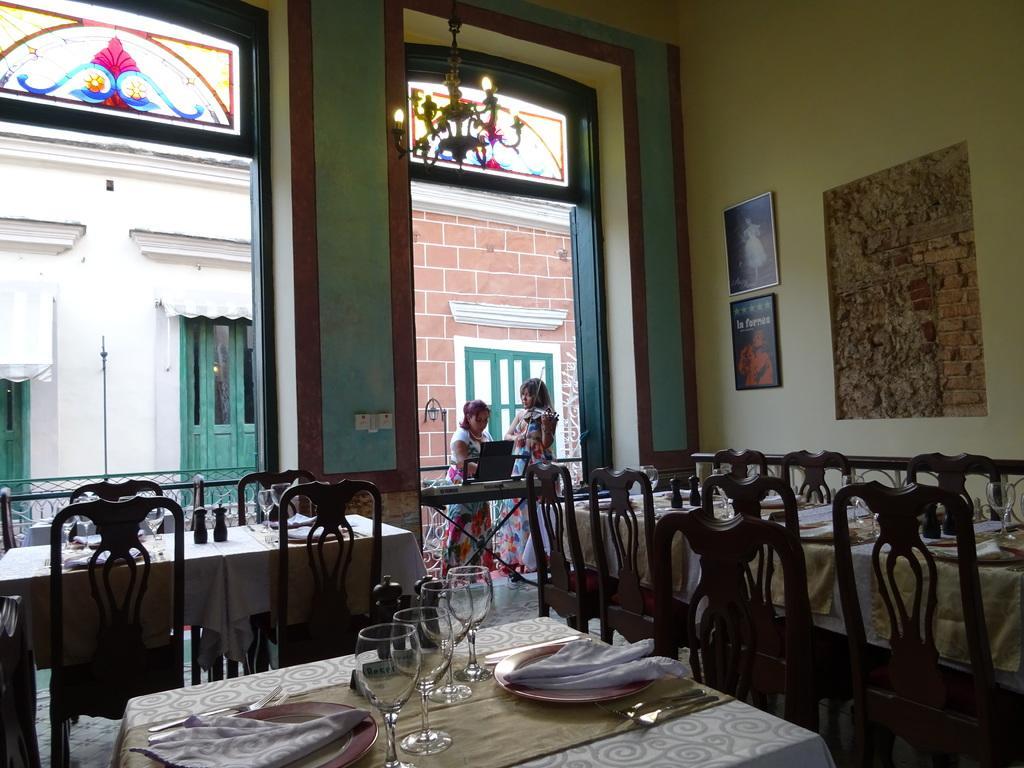Describe this image in one or two sentences. At the bottom of the image there are some chairs and tables, on the tables there are some glasses and plates and spoons and forks. Behind the table there is a wall, on the wall there are some frames and there is a door and two people are standing. 